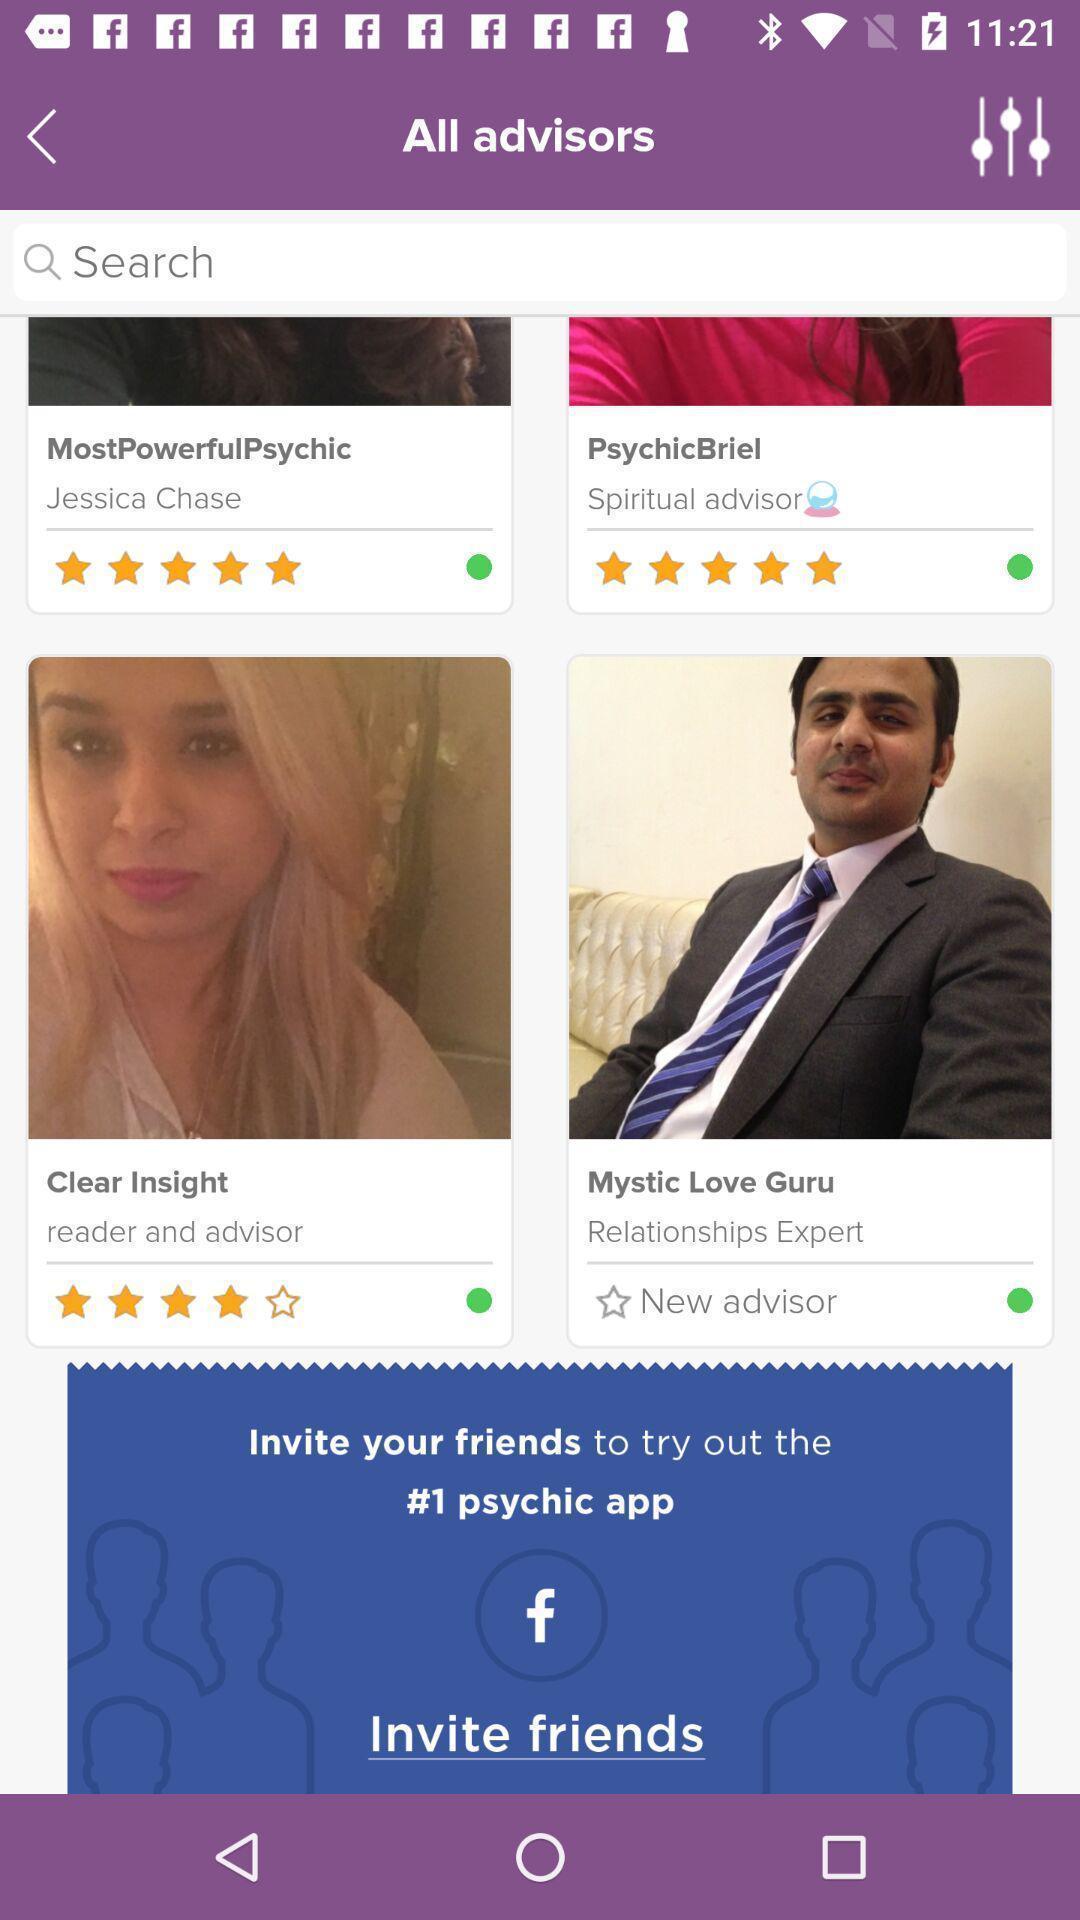Provide a textual representation of this image. Screen displaying various advisors. 